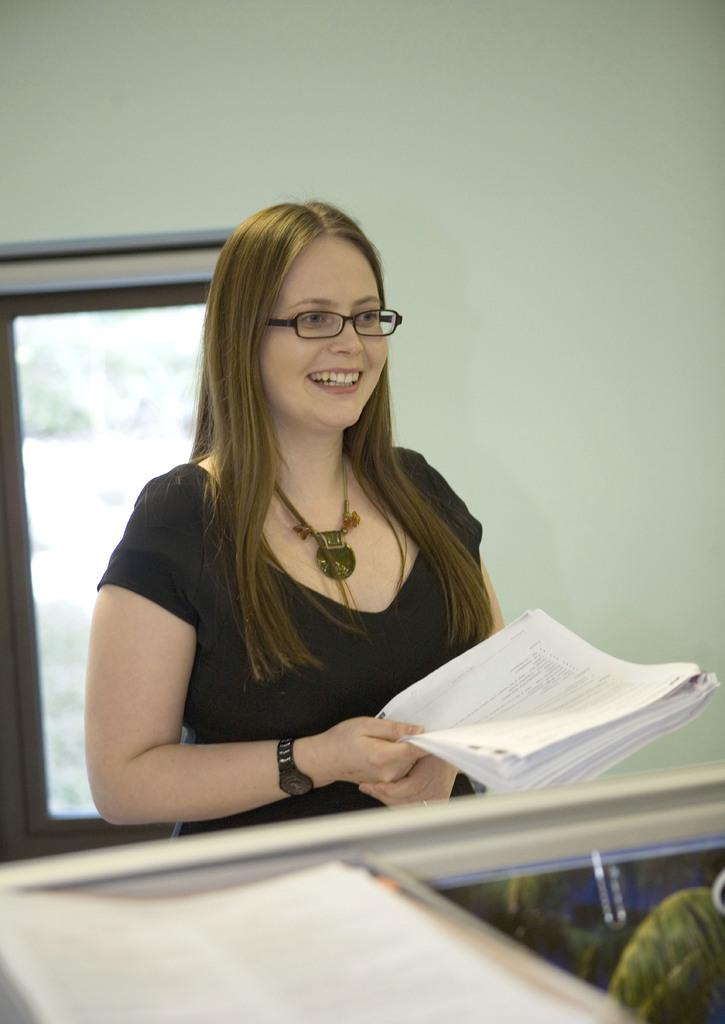Who is the main subject in the image? There is a lady in the center of the image. What is the lady holding in her hand? The lady is holding papers in her hand. What can be seen in the background of the image? There is a wall and a window in the background of the image. What is located at the bottom of the image? There are objects at the bottom of the image. Can you describe the design of the skateboard at the seashore in the image? There is no skateboard or seashore present in the image; it features a lady holding papers in the center of the image with a wall and window in the background. 